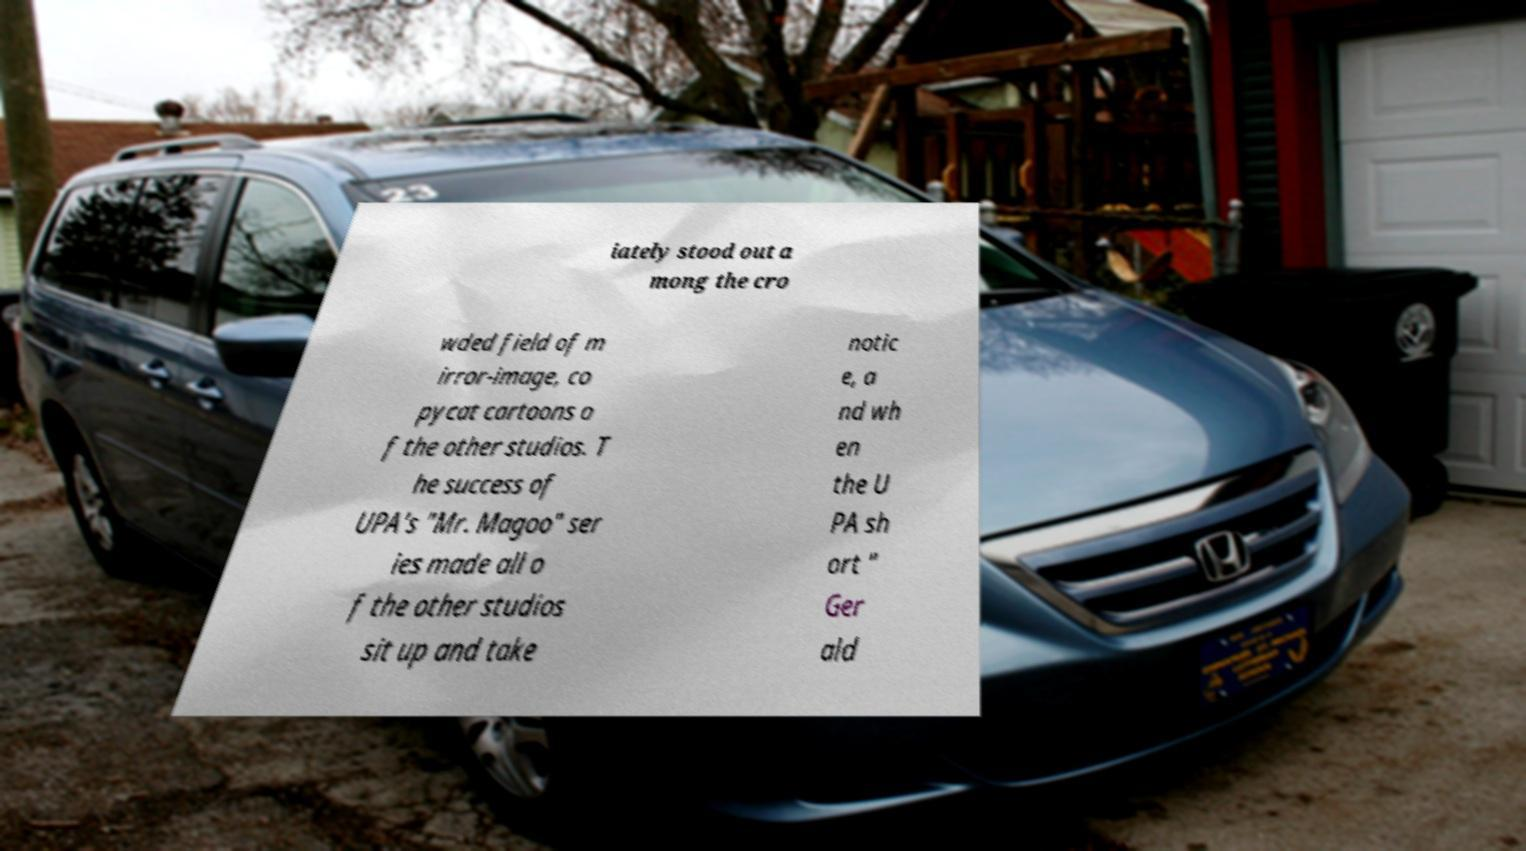Can you read and provide the text displayed in the image?This photo seems to have some interesting text. Can you extract and type it out for me? iately stood out a mong the cro wded field of m irror-image, co pycat cartoons o f the other studios. T he success of UPA's "Mr. Magoo" ser ies made all o f the other studios sit up and take notic e, a nd wh en the U PA sh ort " Ger ald 